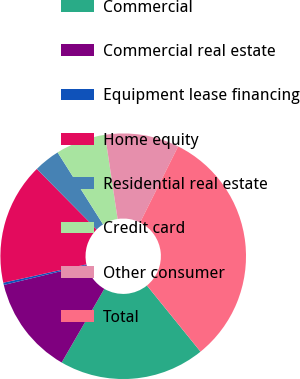Convert chart. <chart><loc_0><loc_0><loc_500><loc_500><pie_chart><fcel>Commercial<fcel>Commercial real estate<fcel>Equipment lease financing<fcel>Home equity<fcel>Residential real estate<fcel>Credit card<fcel>Other consumer<fcel>Total<nl><fcel>19.19%<fcel>12.89%<fcel>0.3%<fcel>16.04%<fcel>3.45%<fcel>6.6%<fcel>9.75%<fcel>31.78%<nl></chart> 